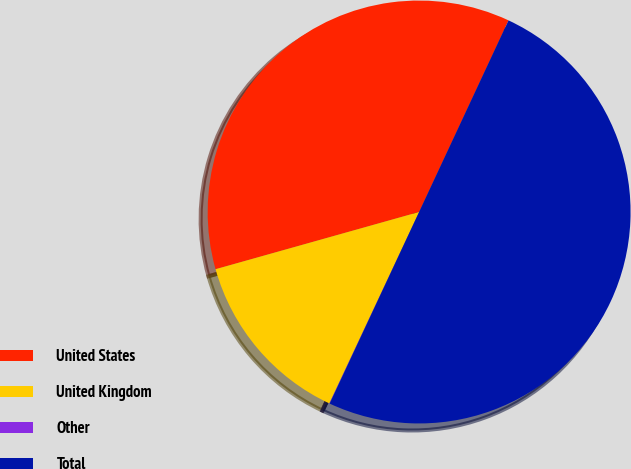<chart> <loc_0><loc_0><loc_500><loc_500><pie_chart><fcel>United States<fcel>United Kingdom<fcel>Other<fcel>Total<nl><fcel>36.31%<fcel>13.66%<fcel>0.03%<fcel>50.0%<nl></chart> 